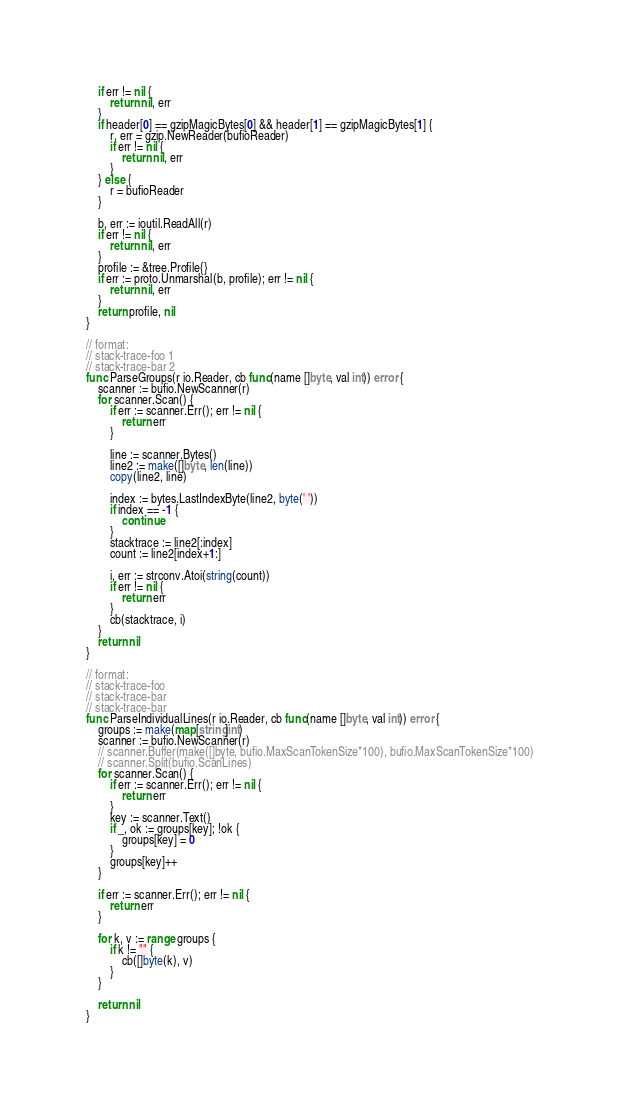<code> <loc_0><loc_0><loc_500><loc_500><_Go_>	if err != nil {
		return nil, err
	}
	if header[0] == gzipMagicBytes[0] && header[1] == gzipMagicBytes[1] {
		r, err = gzip.NewReader(bufioReader)
		if err != nil {
			return nil, err
		}
	} else {
		r = bufioReader
	}

	b, err := ioutil.ReadAll(r)
	if err != nil {
		return nil, err
	}
	profile := &tree.Profile{}
	if err := proto.Unmarshal(b, profile); err != nil {
		return nil, err
	}
	return profile, nil
}

// format:
// stack-trace-foo 1
// stack-trace-bar 2
func ParseGroups(r io.Reader, cb func(name []byte, val int)) error {
	scanner := bufio.NewScanner(r)
	for scanner.Scan() {
		if err := scanner.Err(); err != nil {
			return err
		}

		line := scanner.Bytes()
		line2 := make([]byte, len(line))
		copy(line2, line)

		index := bytes.LastIndexByte(line2, byte(' '))
		if index == -1 {
			continue
		}
		stacktrace := line2[:index]
		count := line2[index+1:]

		i, err := strconv.Atoi(string(count))
		if err != nil {
			return err
		}
		cb(stacktrace, i)
	}
	return nil
}

// format:
// stack-trace-foo
// stack-trace-bar
// stack-trace-bar
func ParseIndividualLines(r io.Reader, cb func(name []byte, val int)) error {
	groups := make(map[string]int)
	scanner := bufio.NewScanner(r)
	// scanner.Buffer(make([]byte, bufio.MaxScanTokenSize*100), bufio.MaxScanTokenSize*100)
	// scanner.Split(bufio.ScanLines)
	for scanner.Scan() {
		if err := scanner.Err(); err != nil {
			return err
		}
		key := scanner.Text()
		if _, ok := groups[key]; !ok {
			groups[key] = 0
		}
		groups[key]++
	}

	if err := scanner.Err(); err != nil {
		return err
	}

	for k, v := range groups {
		if k != "" {
			cb([]byte(k), v)
		}
	}

	return nil
}
</code> 